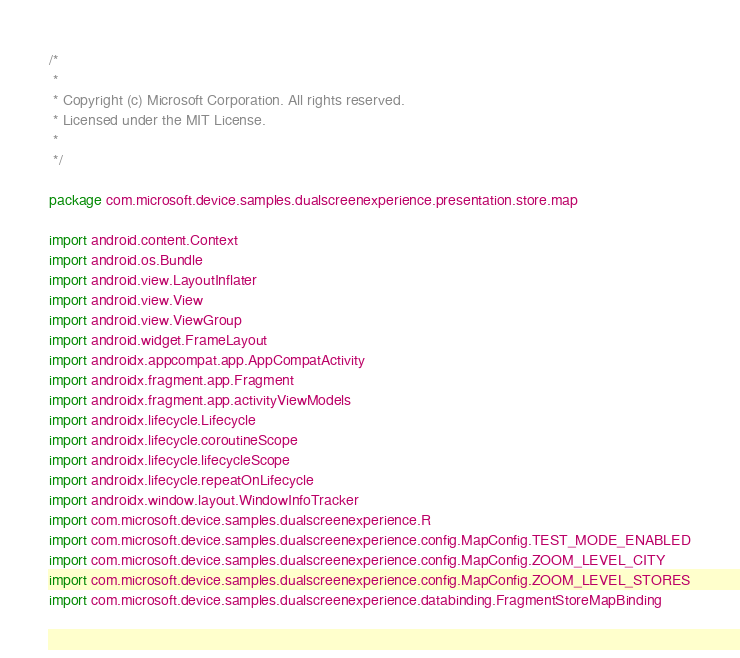<code> <loc_0><loc_0><loc_500><loc_500><_Kotlin_>/*
 *
 * Copyright (c) Microsoft Corporation. All rights reserved.
 * Licensed under the MIT License.
 *
 */

package com.microsoft.device.samples.dualscreenexperience.presentation.store.map

import android.content.Context
import android.os.Bundle
import android.view.LayoutInflater
import android.view.View
import android.view.ViewGroup
import android.widget.FrameLayout
import androidx.appcompat.app.AppCompatActivity
import androidx.fragment.app.Fragment
import androidx.fragment.app.activityViewModels
import androidx.lifecycle.Lifecycle
import androidx.lifecycle.coroutineScope
import androidx.lifecycle.lifecycleScope
import androidx.lifecycle.repeatOnLifecycle
import androidx.window.layout.WindowInfoTracker
import com.microsoft.device.samples.dualscreenexperience.R
import com.microsoft.device.samples.dualscreenexperience.config.MapConfig.TEST_MODE_ENABLED
import com.microsoft.device.samples.dualscreenexperience.config.MapConfig.ZOOM_LEVEL_CITY
import com.microsoft.device.samples.dualscreenexperience.config.MapConfig.ZOOM_LEVEL_STORES
import com.microsoft.device.samples.dualscreenexperience.databinding.FragmentStoreMapBinding</code> 